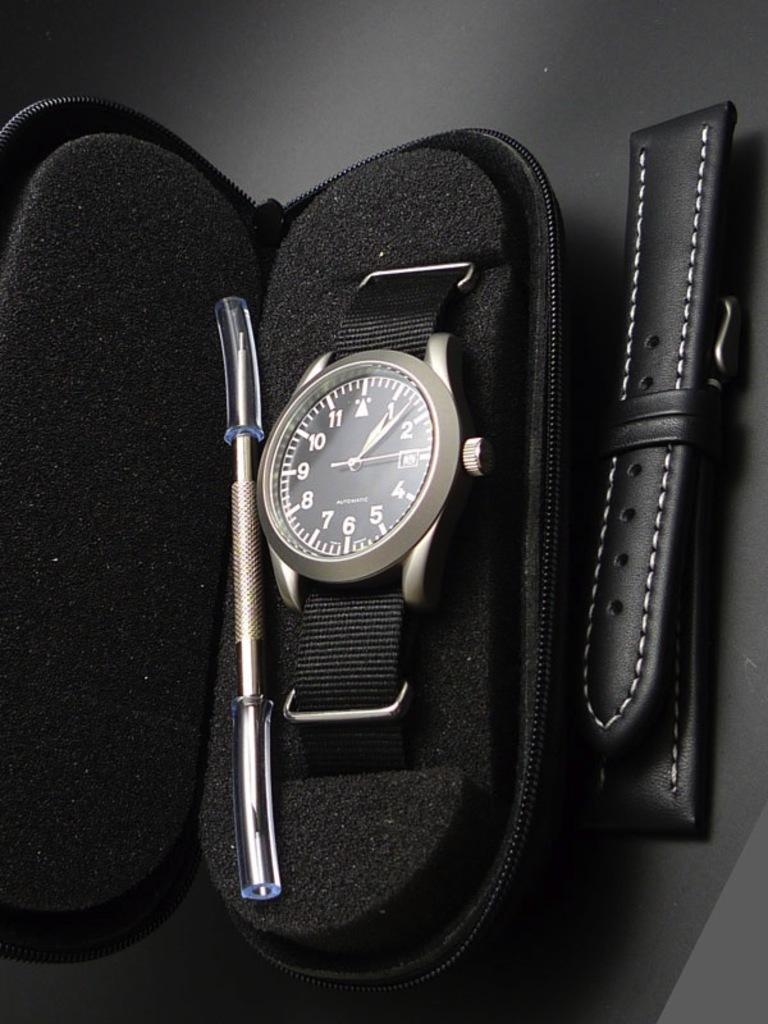<image>
Offer a succinct explanation of the picture presented. A watch in a case that says almost illegibly small Automatic. 